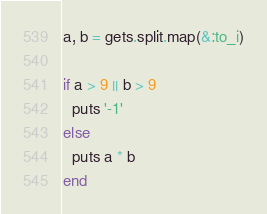Convert code to text. <code><loc_0><loc_0><loc_500><loc_500><_Ruby_>a, b = gets.split.map(&:to_i)

if a > 9 || b > 9
  puts '-1'
else
  puts a * b
end
</code> 